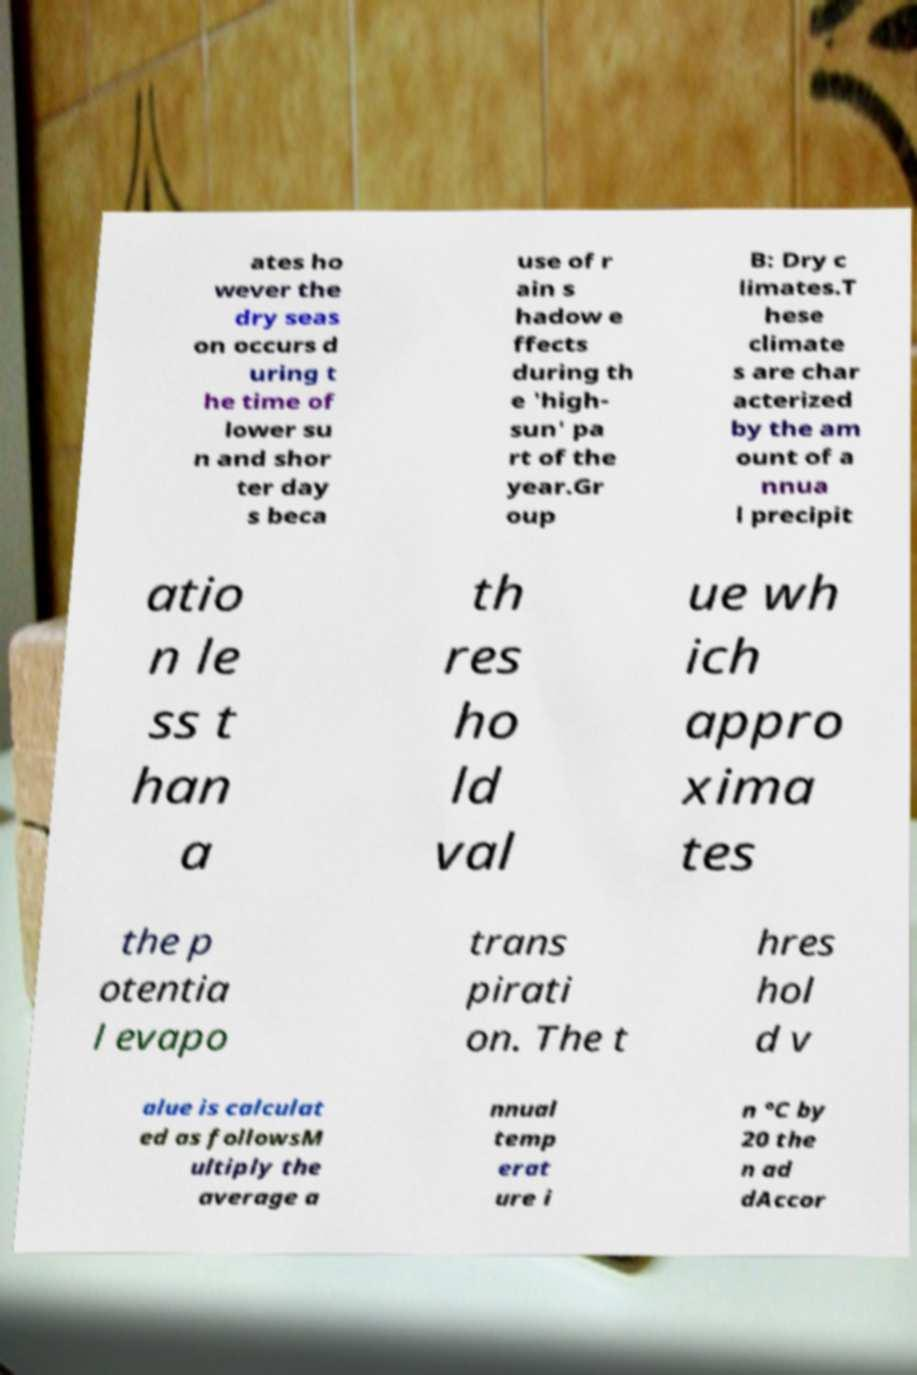For documentation purposes, I need the text within this image transcribed. Could you provide that? ates ho wever the dry seas on occurs d uring t he time of lower su n and shor ter day s beca use of r ain s hadow e ffects during th e 'high- sun' pa rt of the year.Gr oup B: Dry c limates.T hese climate s are char acterized by the am ount of a nnua l precipit atio n le ss t han a th res ho ld val ue wh ich appro xima tes the p otentia l evapo trans pirati on. The t hres hol d v alue is calculat ed as followsM ultiply the average a nnual temp erat ure i n °C by 20 the n ad dAccor 